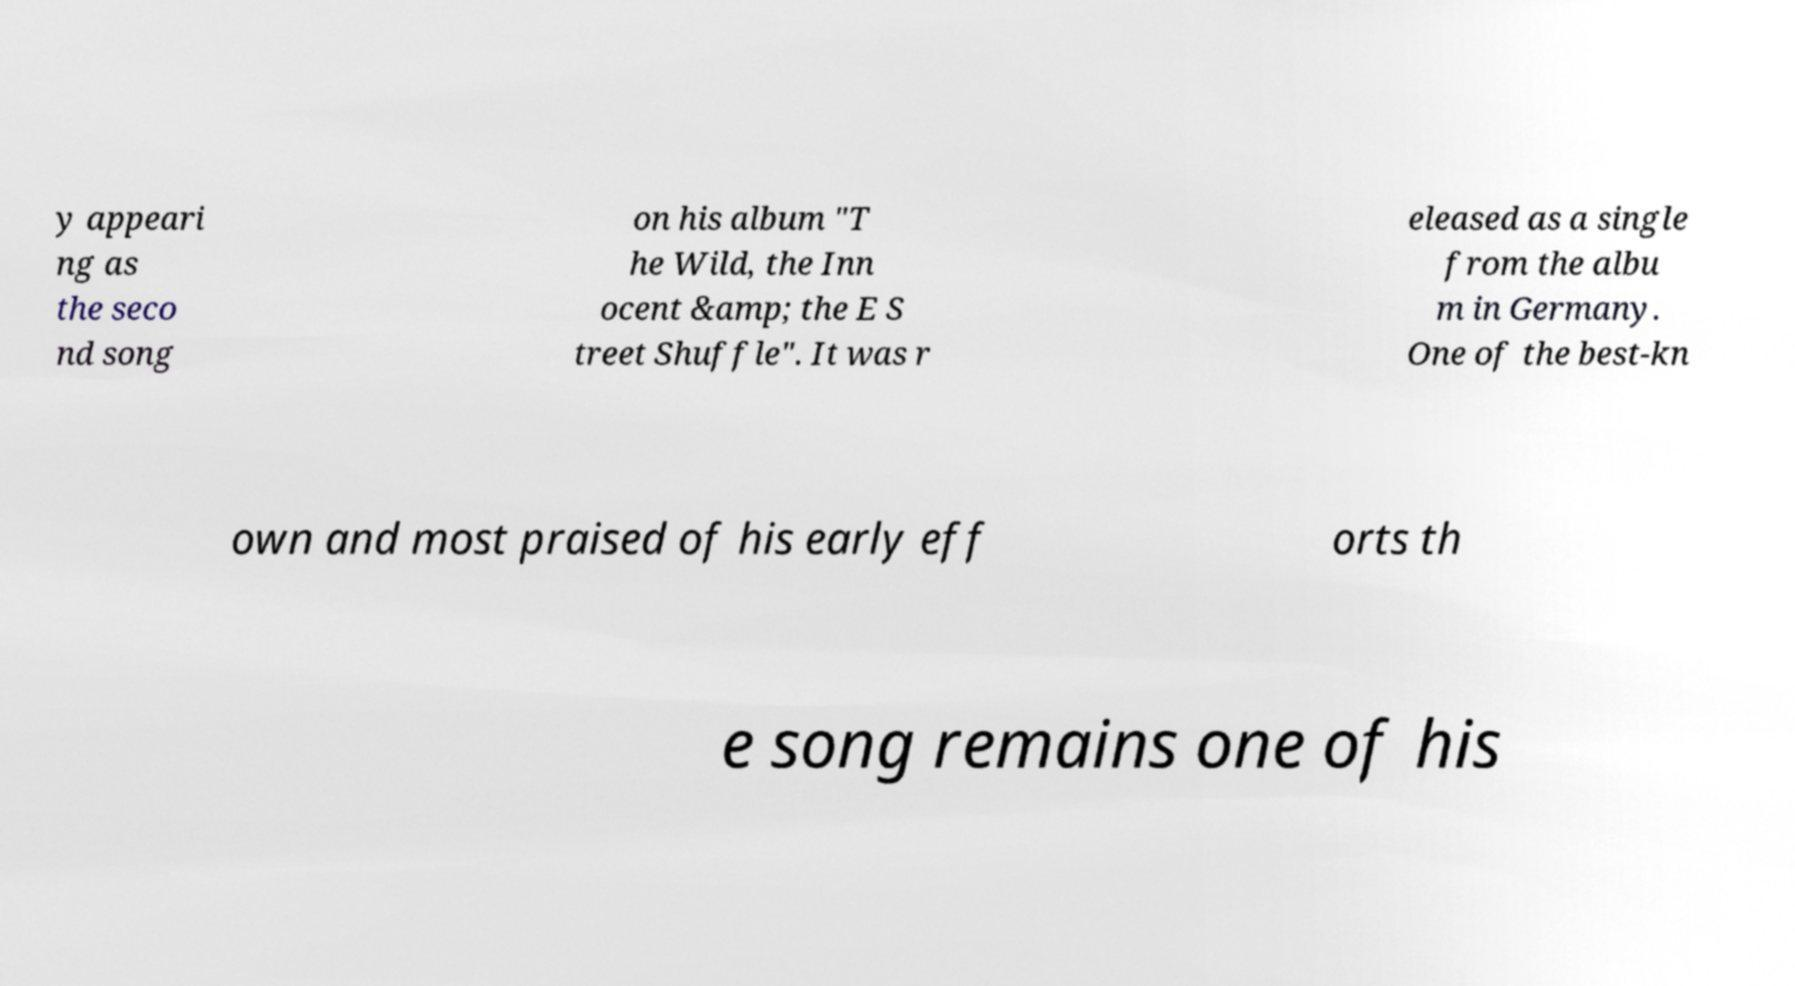There's text embedded in this image that I need extracted. Can you transcribe it verbatim? y appeari ng as the seco nd song on his album "T he Wild, the Inn ocent &amp; the E S treet Shuffle". It was r eleased as a single from the albu m in Germany. One of the best-kn own and most praised of his early eff orts th e song remains one of his 